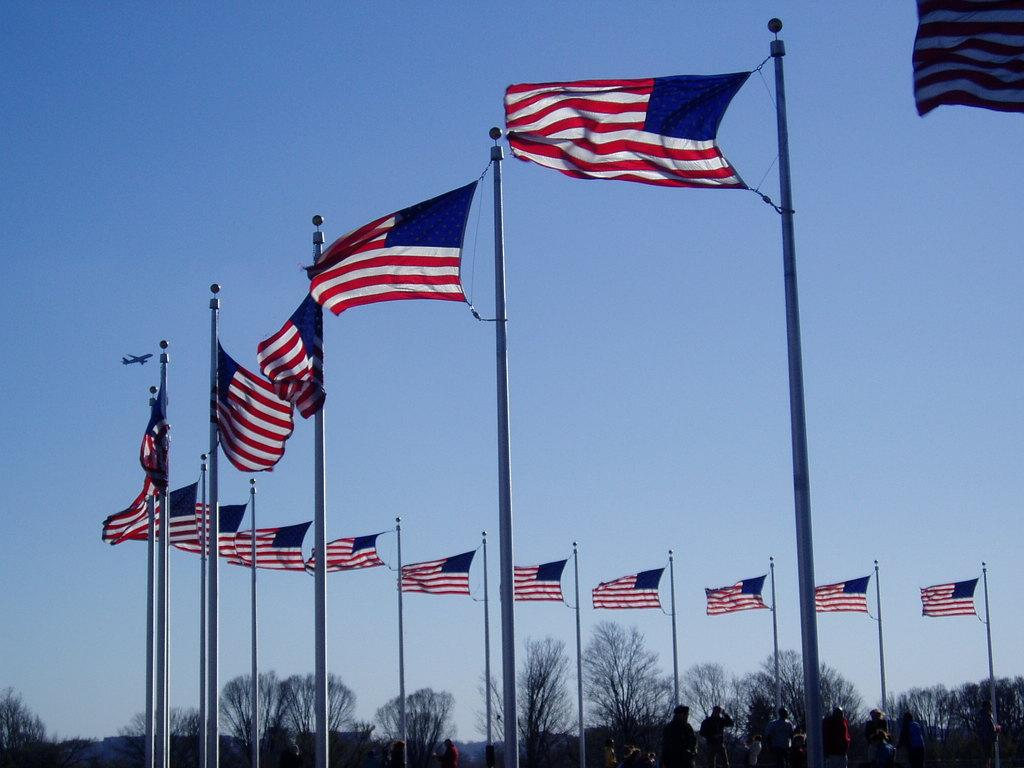What can be seen in the image involving people? There are people standing in the image. What objects are tied to poles in the image? There are flags tied to poles in the image. What type of natural elements are visible in the image? Trees are visible in the image. What is happening in the sky in the image? An airplane is flying in the sky in the image. Where is the bucket located in the image? There is no bucket present in the image. What color is the elbow of the person in the image? It is not possible to determine the color of someone's elbow from the image, as elbows are not visible in the image. 